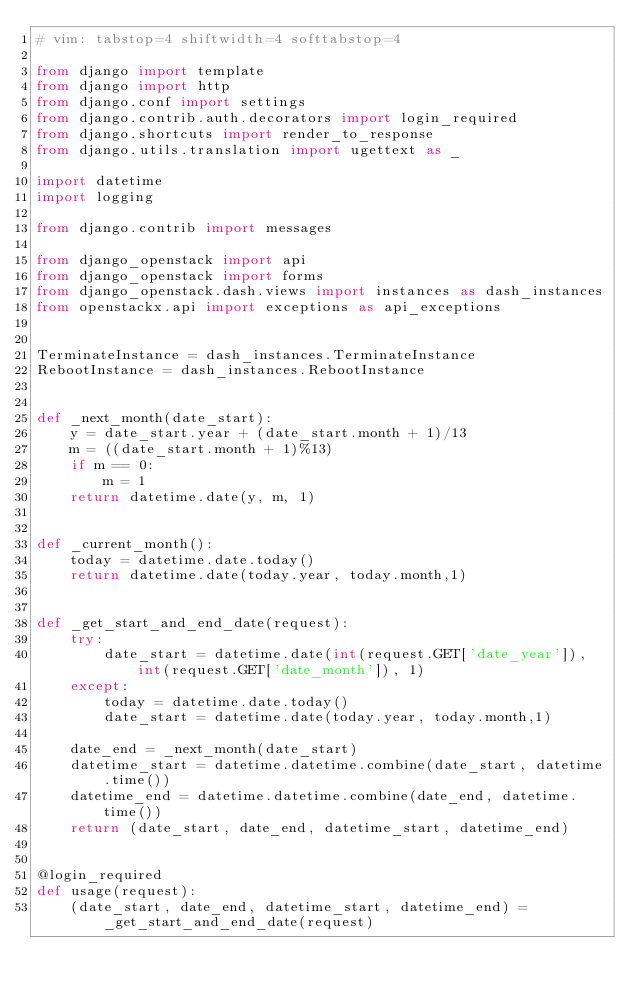<code> <loc_0><loc_0><loc_500><loc_500><_Python_># vim: tabstop=4 shiftwidth=4 softtabstop=4

from django import template
from django import http
from django.conf import settings
from django.contrib.auth.decorators import login_required
from django.shortcuts import render_to_response
from django.utils.translation import ugettext as _

import datetime
import logging

from django.contrib import messages

from django_openstack import api
from django_openstack import forms
from django_openstack.dash.views import instances as dash_instances
from openstackx.api import exceptions as api_exceptions


TerminateInstance = dash_instances.TerminateInstance
RebootInstance = dash_instances.RebootInstance


def _next_month(date_start):
    y = date_start.year + (date_start.month + 1)/13
    m = ((date_start.month + 1)%13)
    if m == 0:
        m = 1
    return datetime.date(y, m, 1)


def _current_month():
    today = datetime.date.today()
    return datetime.date(today.year, today.month,1)


def _get_start_and_end_date(request):
    try:
        date_start = datetime.date(int(request.GET['date_year']), int(request.GET['date_month']), 1)
    except:
        today = datetime.date.today()
        date_start = datetime.date(today.year, today.month,1)

    date_end = _next_month(date_start)
    datetime_start = datetime.datetime.combine(date_start, datetime.time())
    datetime_end = datetime.datetime.combine(date_end, datetime.time())
    return (date_start, date_end, datetime_start, datetime_end)


@login_required
def usage(request):
    (date_start, date_end, datetime_start, datetime_end) = _get_start_and_end_date(request)</code> 